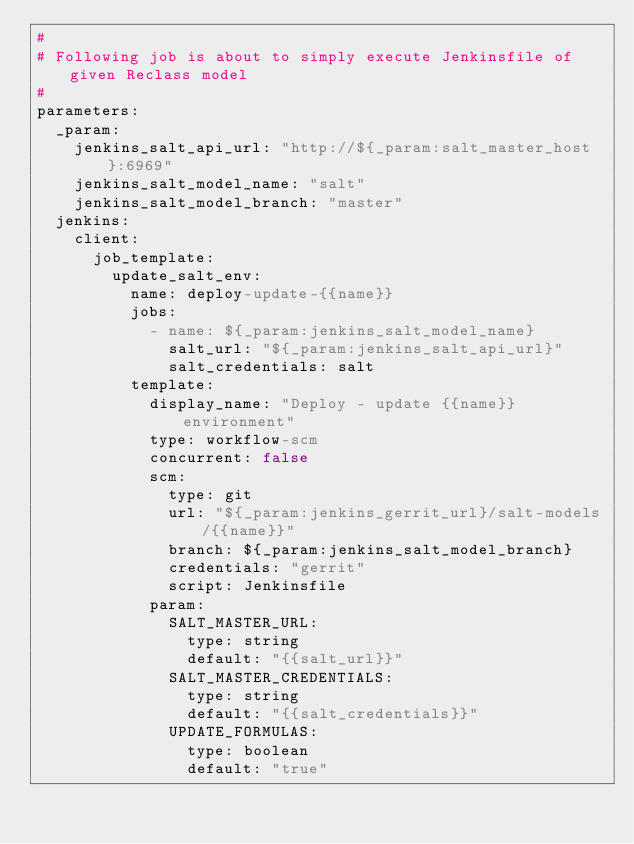Convert code to text. <code><loc_0><loc_0><loc_500><loc_500><_YAML_>#
# Following job is about to simply execute Jenkinsfile of given Reclass model
#
parameters:
  _param:
    jenkins_salt_api_url: "http://${_param:salt_master_host}:6969"
    jenkins_salt_model_name: "salt"
    jenkins_salt_model_branch: "master"
  jenkins:
    client:
      job_template:
        update_salt_env:
          name: deploy-update-{{name}}
          jobs:
            - name: ${_param:jenkins_salt_model_name}
              salt_url: "${_param:jenkins_salt_api_url}"
              salt_credentials: salt
          template:
            display_name: "Deploy - update {{name}} environment"
            type: workflow-scm
            concurrent: false
            scm:
              type: git
              url: "${_param:jenkins_gerrit_url}/salt-models/{{name}}"
              branch: ${_param:jenkins_salt_model_branch}
              credentials: "gerrit"
              script: Jenkinsfile
            param:
              SALT_MASTER_URL:
                type: string
                default: "{{salt_url}}"
              SALT_MASTER_CREDENTIALS:
                type: string
                default: "{{salt_credentials}}"
              UPDATE_FORMULAS:
                type: boolean
                default: "true"
</code> 